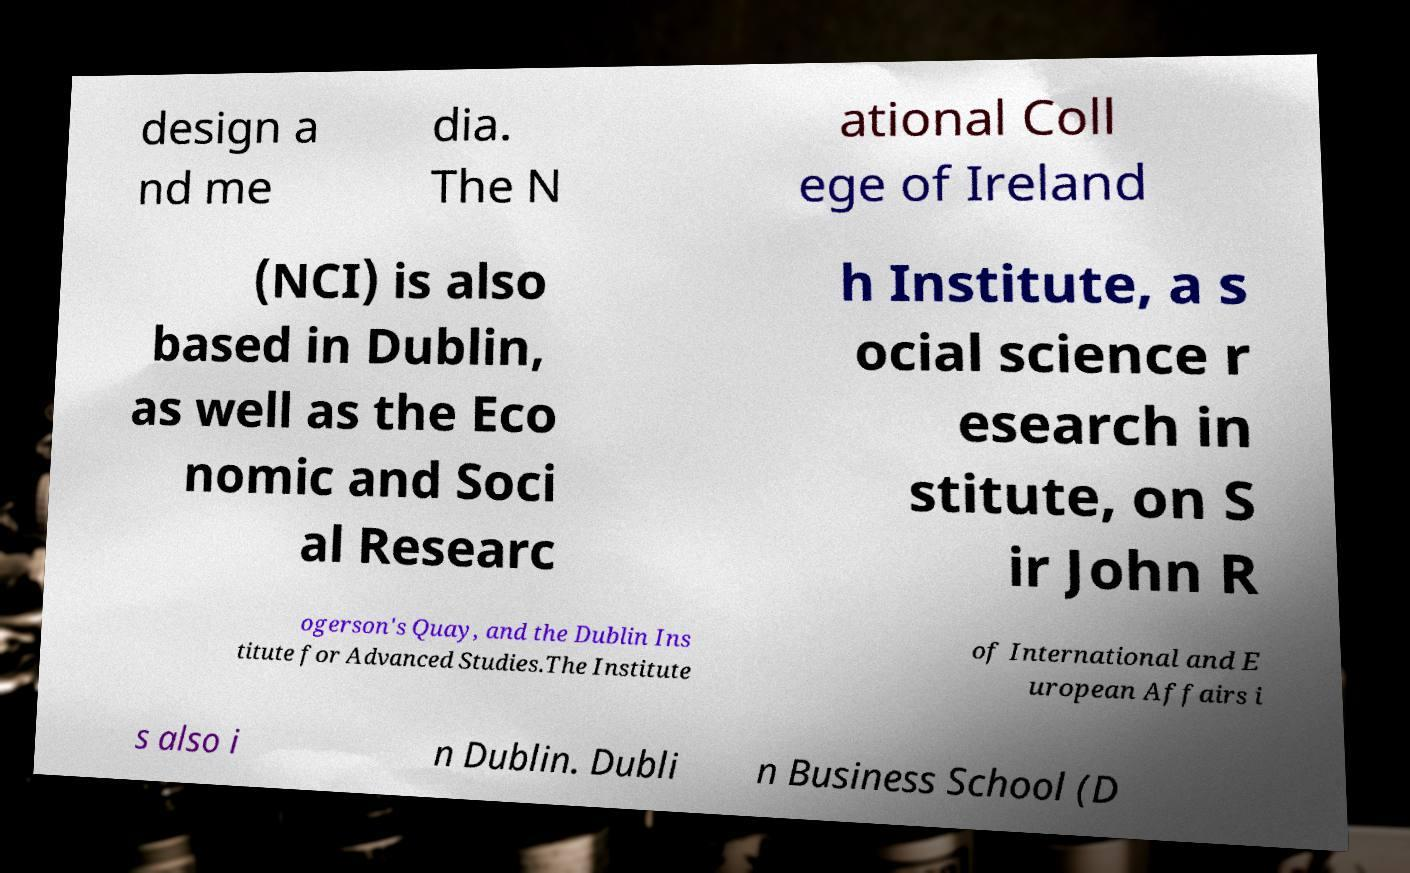Please identify and transcribe the text found in this image. design a nd me dia. The N ational Coll ege of Ireland (NCI) is also based in Dublin, as well as the Eco nomic and Soci al Researc h Institute, a s ocial science r esearch in stitute, on S ir John R ogerson's Quay, and the Dublin Ins titute for Advanced Studies.The Institute of International and E uropean Affairs i s also i n Dublin. Dubli n Business School (D 